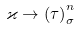<formula> <loc_0><loc_0><loc_500><loc_500>\varkappa \rightarrow \left ( \tau \right ) _ { \sigma } ^ { n }</formula> 